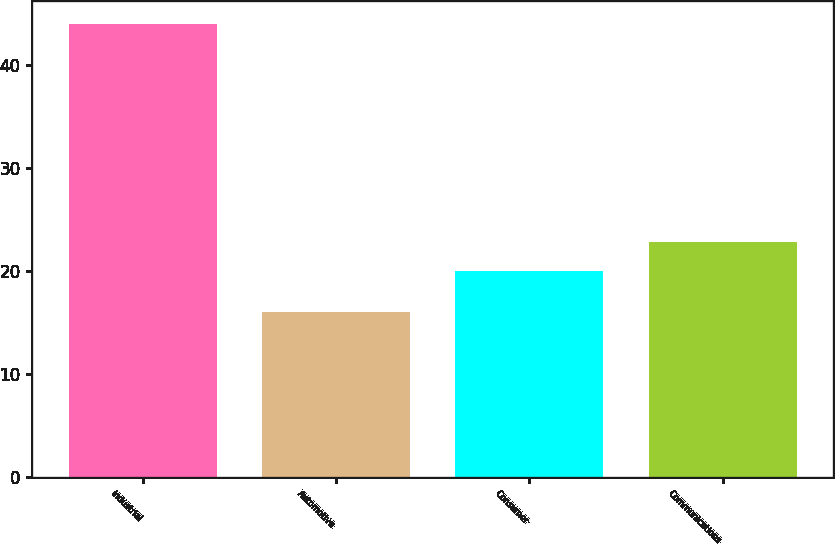Convert chart. <chart><loc_0><loc_0><loc_500><loc_500><bar_chart><fcel>Industrial<fcel>Automotive<fcel>Consumer<fcel>Communications<nl><fcel>44<fcel>16<fcel>20<fcel>22.8<nl></chart> 